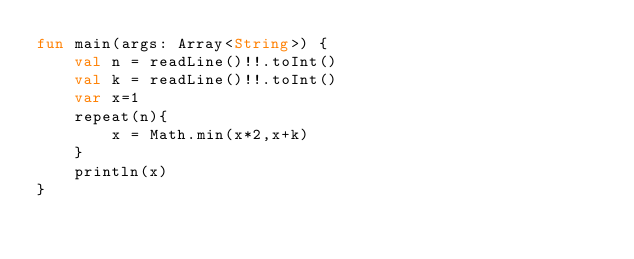<code> <loc_0><loc_0><loc_500><loc_500><_Kotlin_>fun main(args: Array<String>) {
    val n = readLine()!!.toInt()
    val k = readLine()!!.toInt()
    var x=1
    repeat(n){
        x = Math.min(x*2,x+k)
    }
    println(x)
}
</code> 